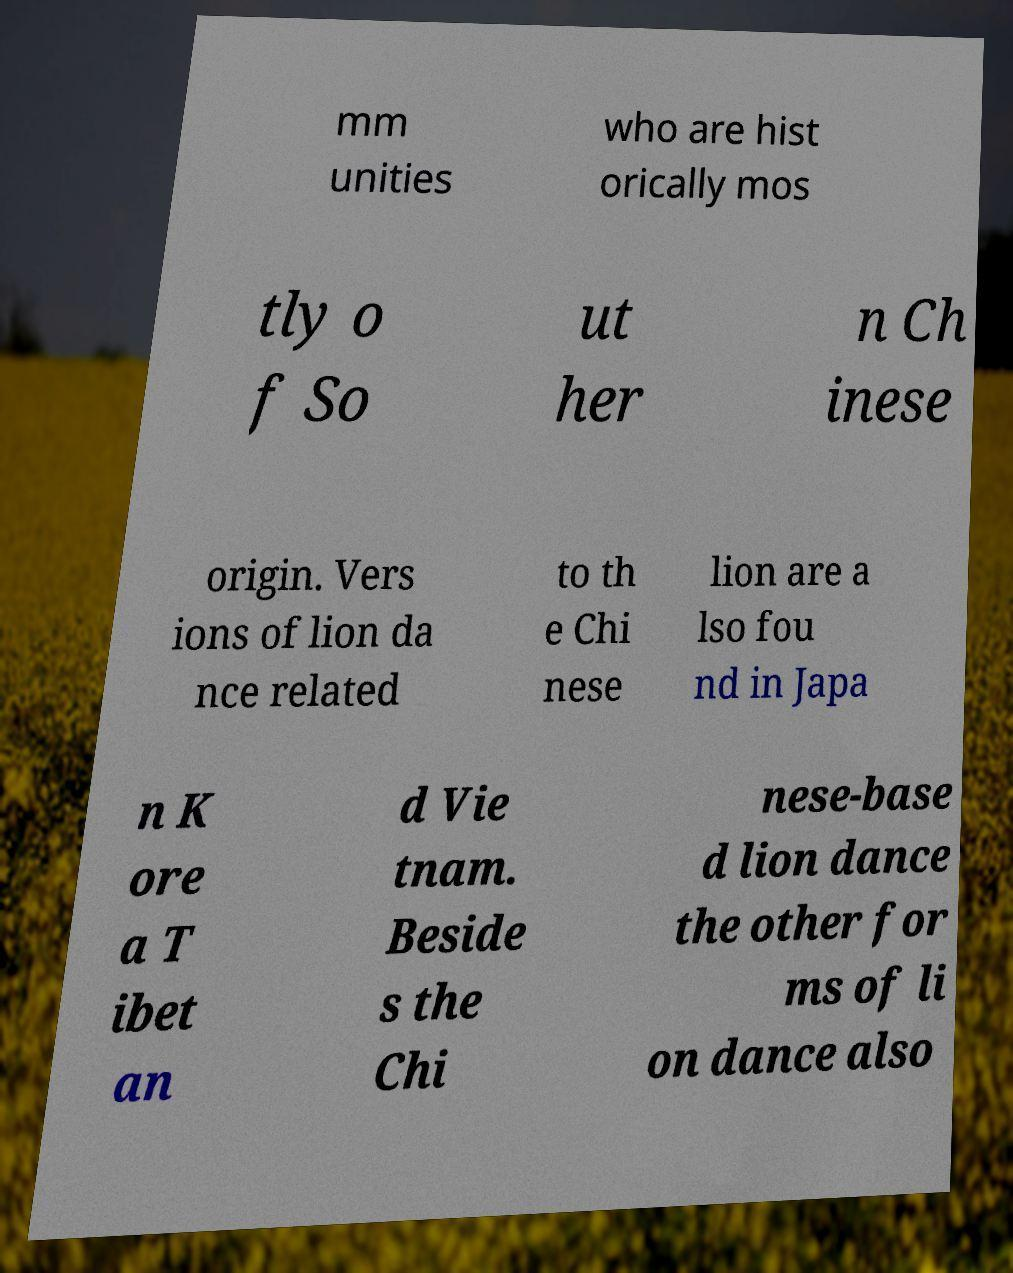Can you read and provide the text displayed in the image?This photo seems to have some interesting text. Can you extract and type it out for me? mm unities who are hist orically mos tly o f So ut her n Ch inese origin. Vers ions of lion da nce related to th e Chi nese lion are a lso fou nd in Japa n K ore a T ibet an d Vie tnam. Beside s the Chi nese-base d lion dance the other for ms of li on dance also 